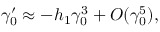<formula> <loc_0><loc_0><loc_500><loc_500>\gamma _ { 0 } ^ { \prime } \approx - h _ { 1 } \gamma _ { 0 } ^ { 3 } + O ( \gamma _ { 0 } ^ { 5 } ) ,</formula> 